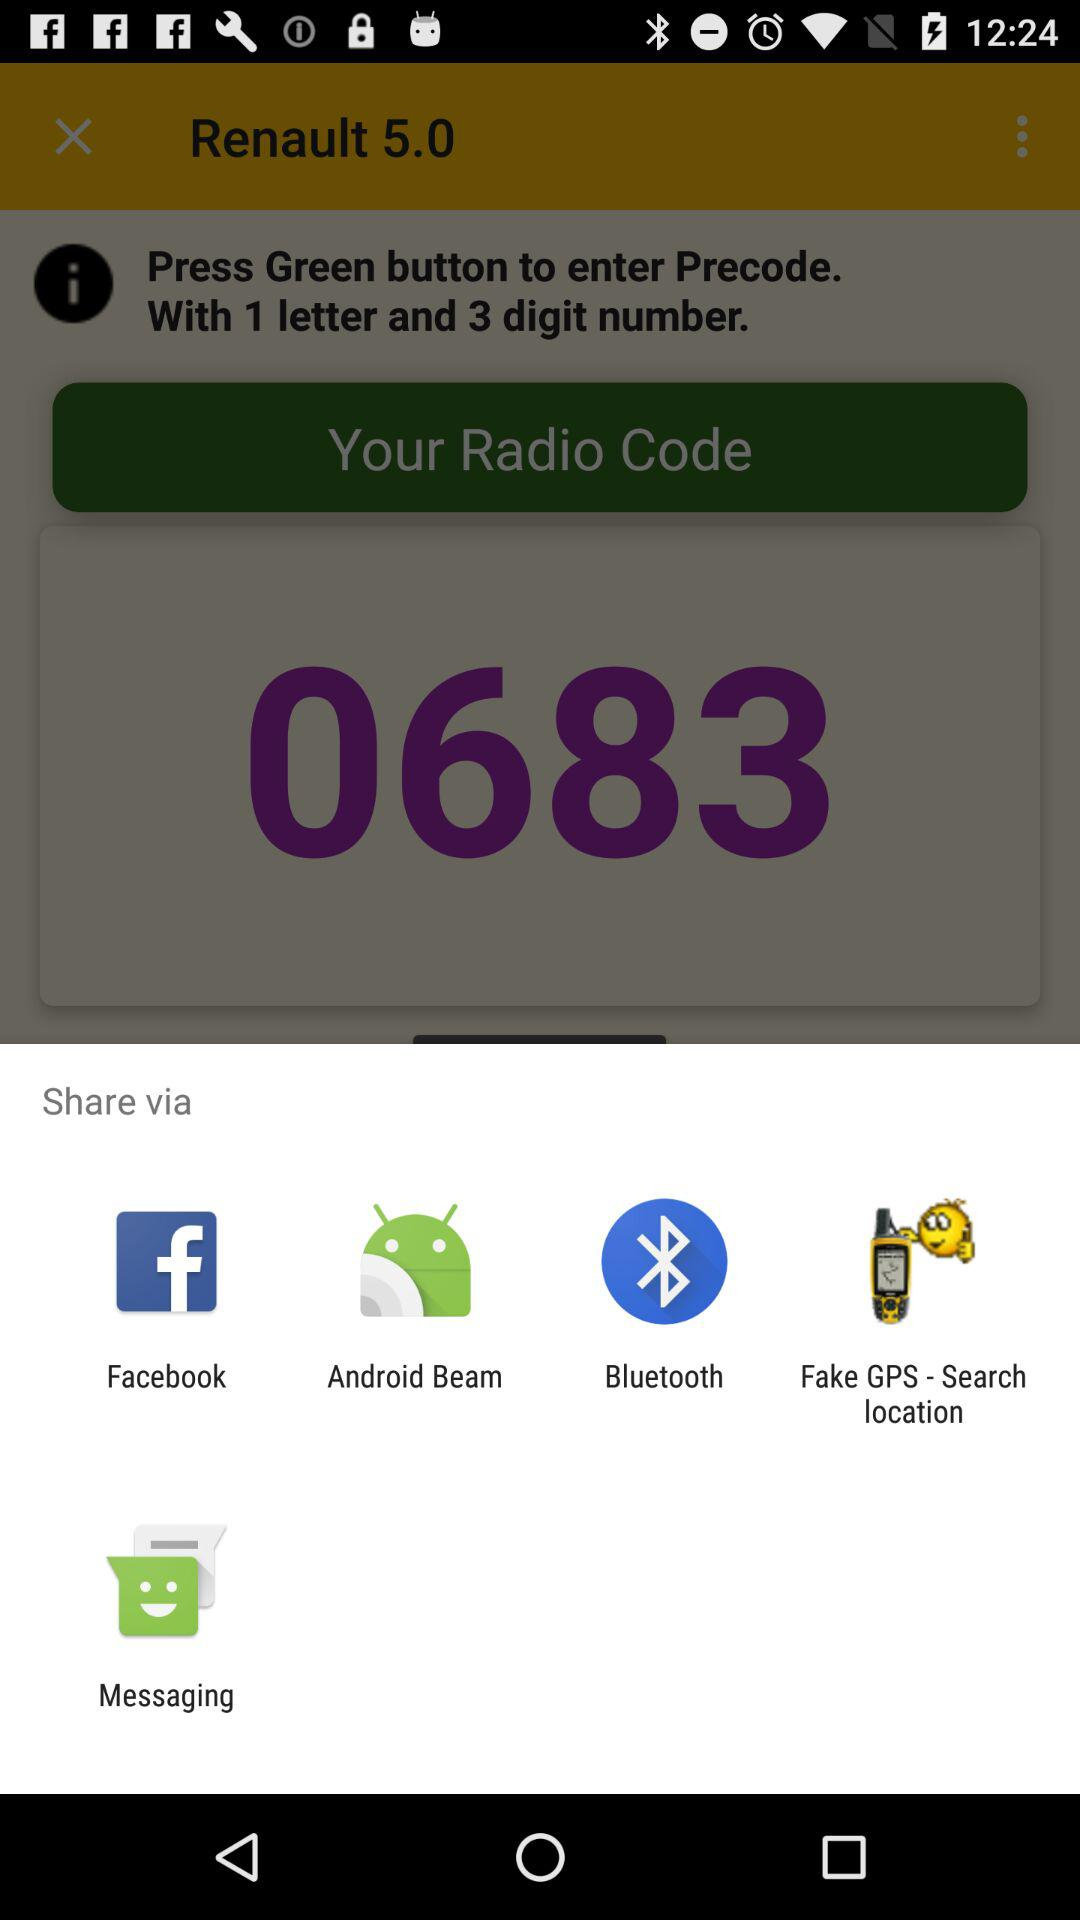What is the version of "Renault"? The version of "Renault" is 5.0. 